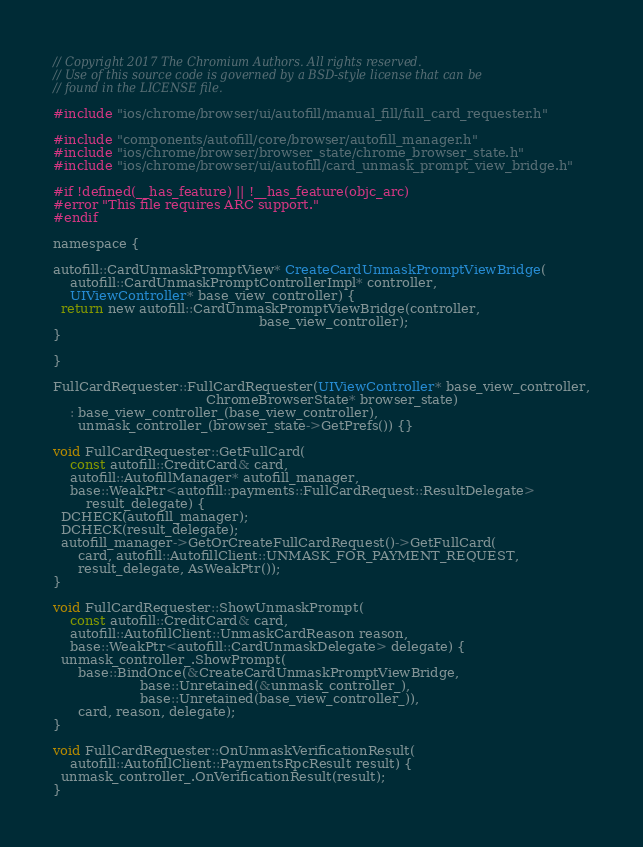Convert code to text. <code><loc_0><loc_0><loc_500><loc_500><_ObjectiveC_>// Copyright 2017 The Chromium Authors. All rights reserved.
// Use of this source code is governed by a BSD-style license that can be
// found in the LICENSE file.

#include "ios/chrome/browser/ui/autofill/manual_fill/full_card_requester.h"

#include "components/autofill/core/browser/autofill_manager.h"
#include "ios/chrome/browser/browser_state/chrome_browser_state.h"
#include "ios/chrome/browser/ui/autofill/card_unmask_prompt_view_bridge.h"

#if !defined(__has_feature) || !__has_feature(objc_arc)
#error "This file requires ARC support."
#endif

namespace {

autofill::CardUnmaskPromptView* CreateCardUnmaskPromptViewBridge(
    autofill::CardUnmaskPromptControllerImpl* controller,
    UIViewController* base_view_controller) {
  return new autofill::CardUnmaskPromptViewBridge(controller,
                                                  base_view_controller);
}

}

FullCardRequester::FullCardRequester(UIViewController* base_view_controller,
                                     ChromeBrowserState* browser_state)
    : base_view_controller_(base_view_controller),
      unmask_controller_(browser_state->GetPrefs()) {}

void FullCardRequester::GetFullCard(
    const autofill::CreditCard& card,
    autofill::AutofillManager* autofill_manager,
    base::WeakPtr<autofill::payments::FullCardRequest::ResultDelegate>
        result_delegate) {
  DCHECK(autofill_manager);
  DCHECK(result_delegate);
  autofill_manager->GetOrCreateFullCardRequest()->GetFullCard(
      card, autofill::AutofillClient::UNMASK_FOR_PAYMENT_REQUEST,
      result_delegate, AsWeakPtr());
}

void FullCardRequester::ShowUnmaskPrompt(
    const autofill::CreditCard& card,
    autofill::AutofillClient::UnmaskCardReason reason,
    base::WeakPtr<autofill::CardUnmaskDelegate> delegate) {
  unmask_controller_.ShowPrompt(
      base::BindOnce(&CreateCardUnmaskPromptViewBridge,
                     base::Unretained(&unmask_controller_),
                     base::Unretained(base_view_controller_)),
      card, reason, delegate);
}

void FullCardRequester::OnUnmaskVerificationResult(
    autofill::AutofillClient::PaymentsRpcResult result) {
  unmask_controller_.OnVerificationResult(result);
}
</code> 